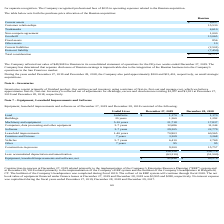According to Chefs Wharehouse's financial document, What is the useful lives of buildings? According to the financial document, 20 years. The relevant text states: "Buildings 20 years 1,360 1,292..." Also, What is the useful lives of Machinery and equipment? According to the financial document, 5-10 years. The relevant text states: "Machinery and equipment 5-10 years 21,718 17,837..." Also, What is the useful lives of Computers, data processing and other equipment? According to the financial document, 3-7 years. The relevant text states: "Computers, data processing and other equipment 3-7 years 12,686 11,244..." Also, can you calculate: What is the difference in useful lives between buildings and that of Furniture and fixtures? Based on the calculation: 20-7, the result is 13. This is based on the information: "Useful Lives December 27, 2019 December 28, 2018 Useful Lives December 27, 2019 December 28, 2018..." The key data points involved are: 20, 7. Also, can you calculate: What is the average value of vehicles for 2018 and 2019? To answer this question, I need to perform calculations using the financial data. The calculation is: (6,410+2,769)/2, which equals 4589.5. This is based on the information: "Vehicles 5-7 years 6,410 2,769 Vehicles 5-7 years 6,410 2,769..." The key data points involved are: 2,769, 6,410. Also, can you calculate: What is the average value of buildings for 2018 and 2019? To answer this question, I need to perform calculations using the financial data. The calculation is: (1,360+ 1,292)/2, which equals 1326. This is based on the information: "Buildings 20 years 1,360 1,292 Buildings 20 years 1,360 1,292..." The key data points involved are: 1,292, 1,360. 